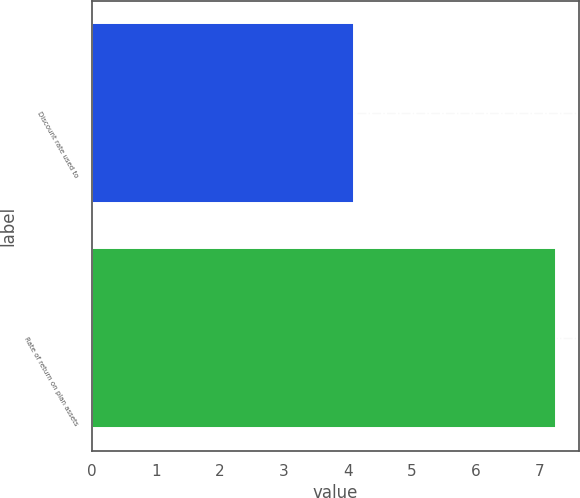<chart> <loc_0><loc_0><loc_500><loc_500><bar_chart><fcel>Discount rate used to<fcel>Rate of return on plan assets<nl><fcel>4.09<fcel>7.25<nl></chart> 